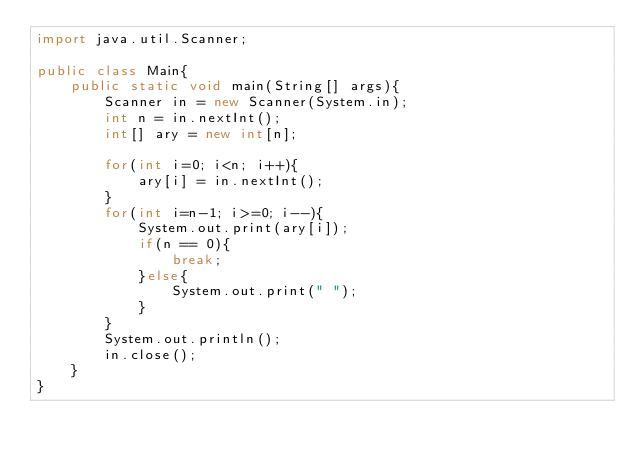Convert code to text. <code><loc_0><loc_0><loc_500><loc_500><_Java_>import java.util.Scanner;

public class Main{
	public static void main(String[] args){
		Scanner in = new Scanner(System.in);
		int n = in.nextInt();
		int[] ary = new int[n];
		
		for(int i=0; i<n; i++){
			ary[i] = in.nextInt();
		}
		for(int i=n-1; i>=0; i--){
			System.out.print(ary[i]);
			if(n == 0){
				break;
			}else{
				System.out.print(" ");
			}
		}
		System.out.println();
		in.close();
	}
}</code> 